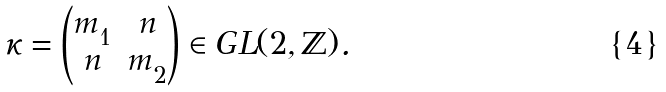<formula> <loc_0><loc_0><loc_500><loc_500>\kappa = \begin{pmatrix} m ^ { \ } _ { 1 } & n \\ n & m ^ { \ } _ { 2 } \end{pmatrix} \in G L ( 2 , \mathbb { Z } ) .</formula> 